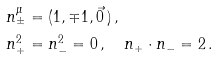Convert formula to latex. <formula><loc_0><loc_0><loc_500><loc_500>& n _ { \pm } ^ { \mu } = ( 1 , \mp 1 , \vec { 0 } \, ) \, , \\ & n _ { + } ^ { 2 } = n _ { - } ^ { 2 } = 0 \, , \quad n _ { + } \cdot n _ { - } = 2 \, .</formula> 